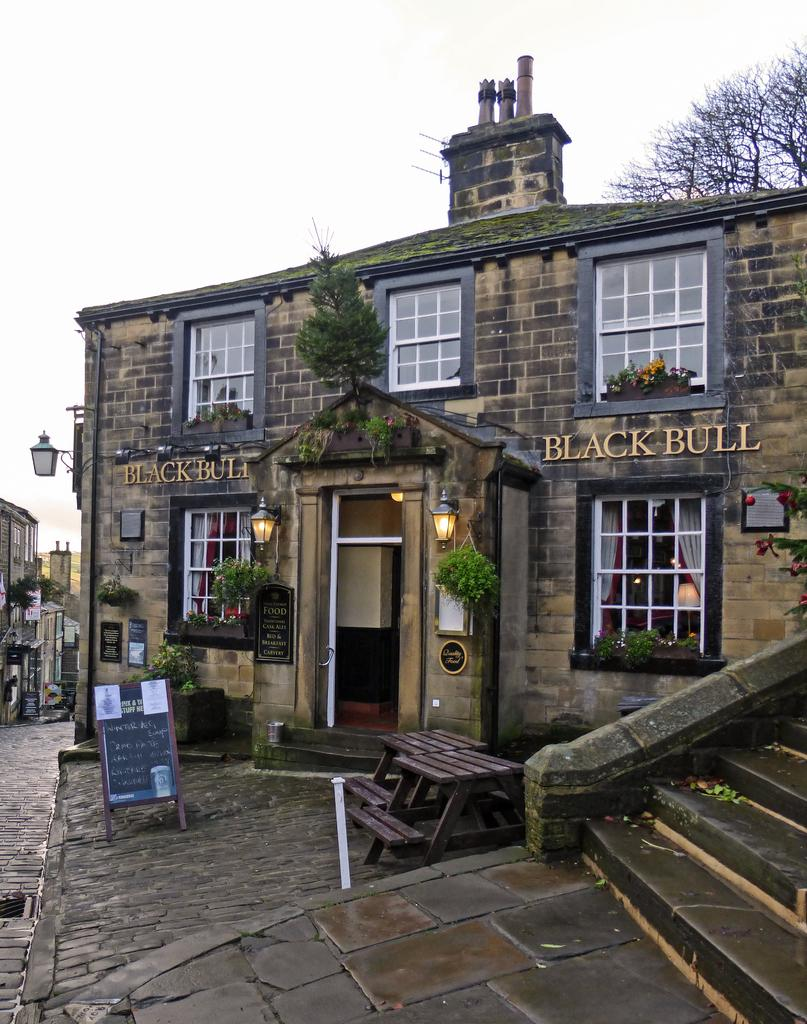What color is the house in the image? The house in the image is brown. What type of windows does the house have? The house has white glass windows. Are there any lighting fixtures on the house? Yes, the house has wall lights. What architectural feature is present at the bottom of the image? There are steps in the front bottom side of the image. What can be seen in the background of the image? There is a dry tree and the sky visible in the background of the image. What type of tail can be seen on the house in the image? There is no tail present on the house in the image. What is the house's opinion on the current political climate in the image? The house is an inanimate object and cannot have an opinion or mind. 